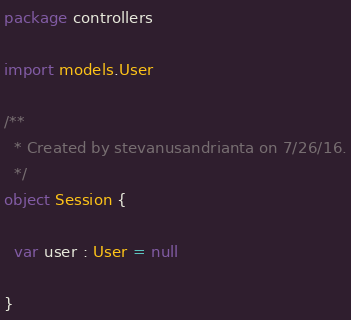Convert code to text. <code><loc_0><loc_0><loc_500><loc_500><_Scala_>package controllers

import models.User

/**
  * Created by stevanusandrianta on 7/26/16.
  */
object Session {

  var user : User = null

}
</code> 